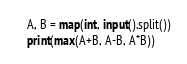<code> <loc_0><loc_0><loc_500><loc_500><_Python_>A, B = map(int, input().split())
print(max(A+B, A-B, A*B))</code> 